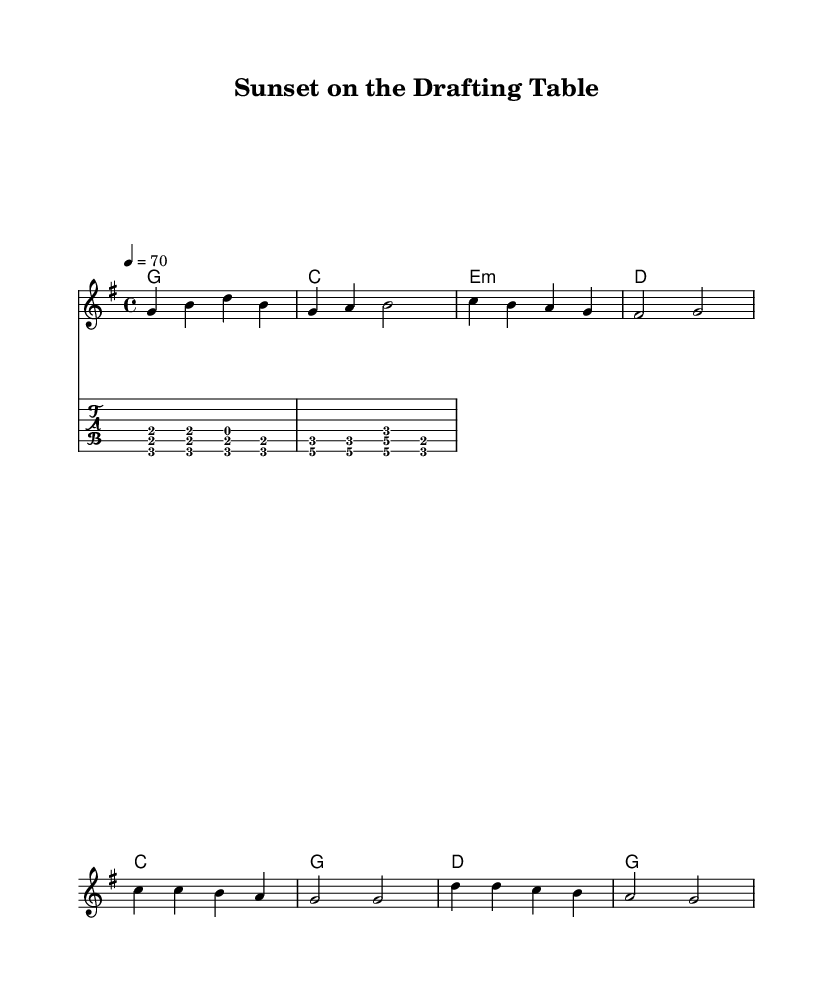What is the key signature of this music? The key signature is G major, which has one sharp (F#).
Answer: G major What is the time signature of this piece? The time signature is 4/4, indicating four beats per measure.
Answer: 4/4 What is the tempo marking for this piece? The tempo marking is 70 beats per minute, indicating a relaxed pace suitable for unwinding.
Answer: 70 How many measures are in the verse section? The verse has four measures, as indicated by the grouping of the notes in the melody and the harmonies.
Answer: Four What chords are used in the chorus? The chorus uses the chords C, G, D, and G, which are standard chords for country rock tunes.
Answer: C, G, D, G What is the main theme of the lyrics? The main theme is about releasing stress and enjoying relaxed moments at the end of the day, which is characteristic of laid-back country rock tunes.
Answer: Stress relief What is the instrumental accompaniment used in this piece? The instrumental accompaniment includes a guitar riff that complements the vocals and adds a country feel.
Answer: Guitar riff 